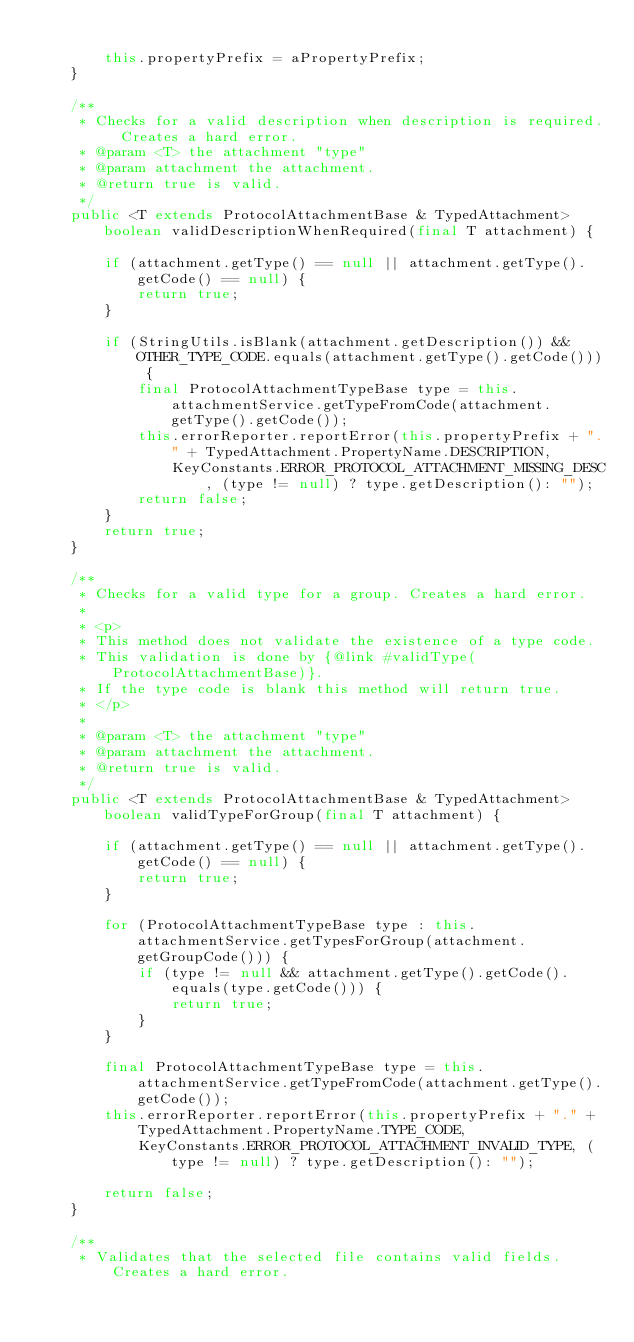<code> <loc_0><loc_0><loc_500><loc_500><_Java_>        
        this.propertyPrefix = aPropertyPrefix;
    }
    
    /**
     * Checks for a valid description when description is required. Creates a hard error.
     * @param <T> the attachment "type"
     * @param attachment the attachment.
     * @return true is valid.
     */
    public <T extends ProtocolAttachmentBase & TypedAttachment> boolean validDescriptionWhenRequired(final T attachment) {
        
        if (attachment.getType() == null || attachment.getType().getCode() == null) {
            return true;
        }
        
        if (StringUtils.isBlank(attachment.getDescription()) && OTHER_TYPE_CODE.equals(attachment.getType().getCode())) {
            final ProtocolAttachmentTypeBase type = this.attachmentService.getTypeFromCode(attachment.getType().getCode());
            this.errorReporter.reportError(this.propertyPrefix + "." + TypedAttachment.PropertyName.DESCRIPTION,
                KeyConstants.ERROR_PROTOCOL_ATTACHMENT_MISSING_DESC, (type != null) ? type.getDescription(): "");
            return false;
        }
        return true;
    }
    
    /**
     * Checks for a valid type for a group. Creates a hard error.
     * 
     * <p>
     * This method does not validate the existence of a type code.
     * This validation is done by {@link #validType(ProtocolAttachmentBase)}.
     * If the type code is blank this method will return true.
     * </p>
     * 
     * @param <T> the attachment "type"
     * @param attachment the attachment.
     * @return true is valid.
     */
    public <T extends ProtocolAttachmentBase & TypedAttachment> boolean validTypeForGroup(final T attachment) {
        
        if (attachment.getType() == null || attachment.getType().getCode() == null) {
            return true;
        }
        
        for (ProtocolAttachmentTypeBase type : this.attachmentService.getTypesForGroup(attachment.getGroupCode())) {
            if (type != null && attachment.getType().getCode().equals(type.getCode())) {
                return true;
            }
        }
        
        final ProtocolAttachmentTypeBase type = this.attachmentService.getTypeFromCode(attachment.getType().getCode());
        this.errorReporter.reportError(this.propertyPrefix + "." + TypedAttachment.PropertyName.TYPE_CODE,
            KeyConstants.ERROR_PROTOCOL_ATTACHMENT_INVALID_TYPE, (type != null) ? type.getDescription(): "");
        
        return false;
    }
    
    /**
     * Validates that the selected file contains valid fields. Creates a hard error.
</code> 